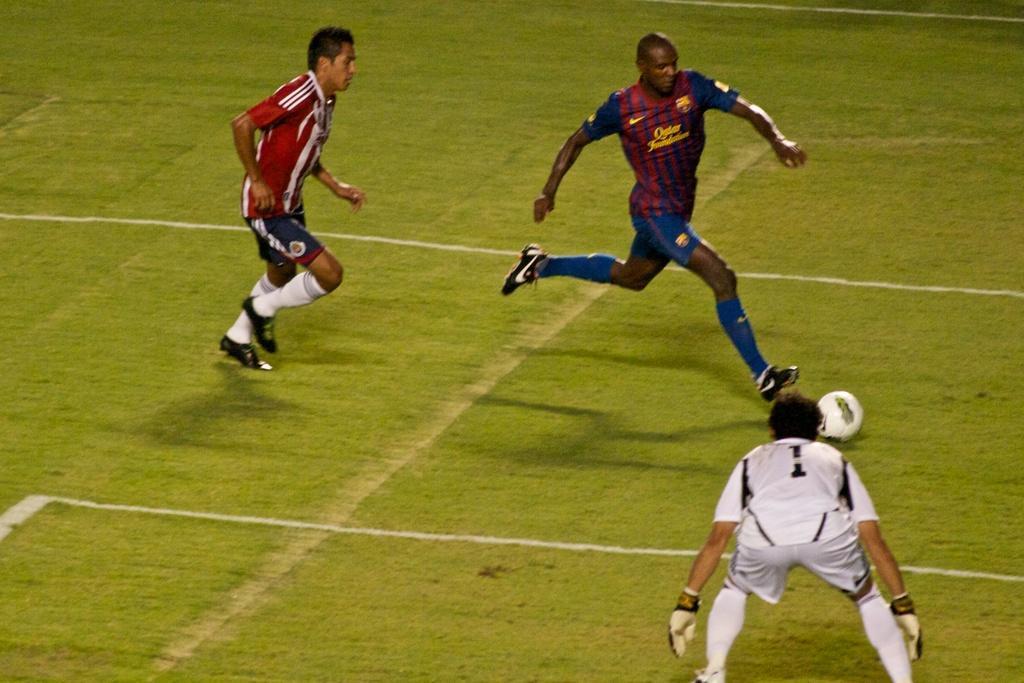How would you summarize this image in a sentence or two? In this image I can see three persons playing game, in front the person is wearing white dress and the person at back wearing white and red dress, and the person at left wearing red and black dress. I can also see ball in white color. 